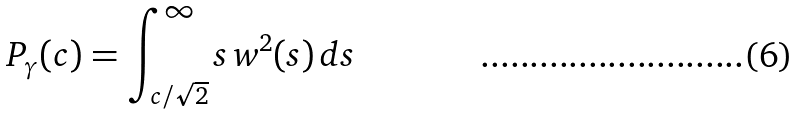Convert formula to latex. <formula><loc_0><loc_0><loc_500><loc_500>P _ { \gamma } ( c ) = \int _ { c / \sqrt { 2 } } ^ { \infty } s \, w ^ { 2 } ( s ) \, d s</formula> 